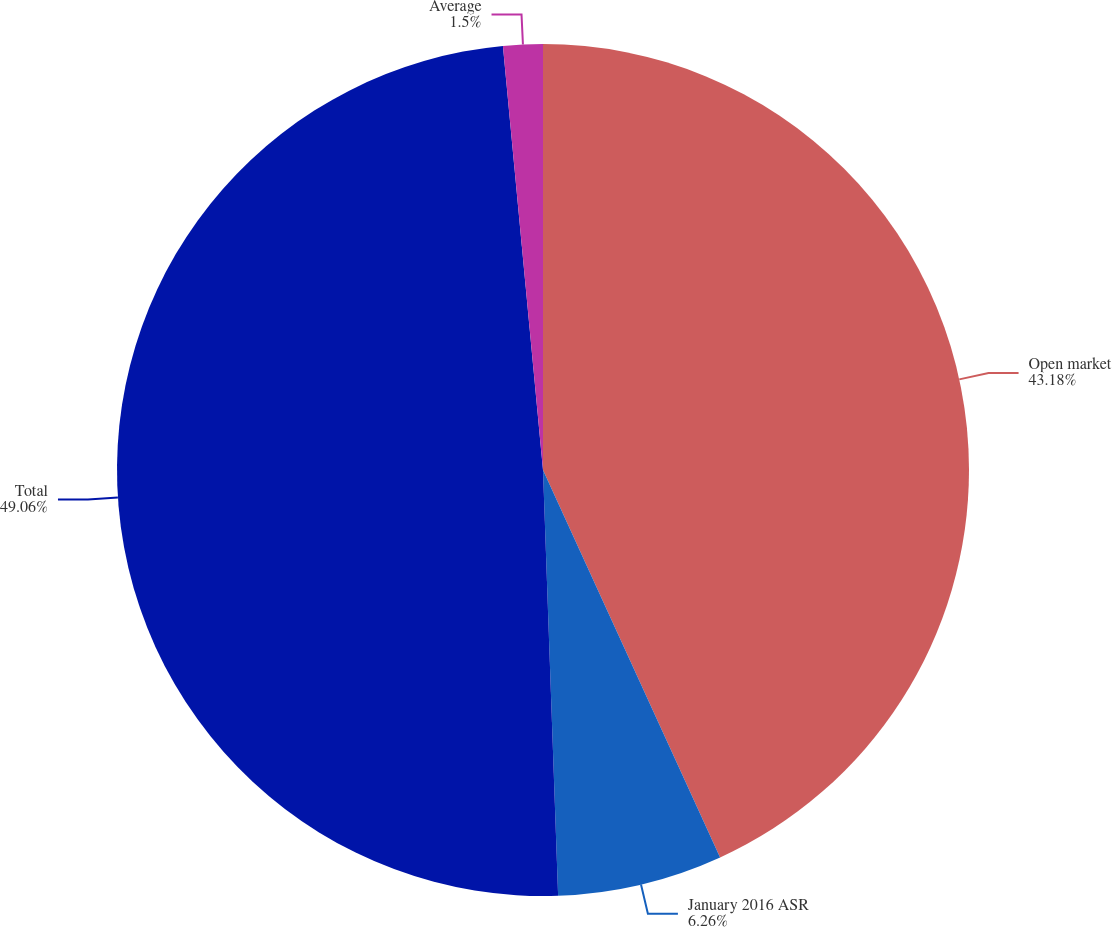Convert chart to OTSL. <chart><loc_0><loc_0><loc_500><loc_500><pie_chart><fcel>Open market<fcel>January 2016 ASR<fcel>Total<fcel>Average<nl><fcel>43.18%<fcel>6.26%<fcel>49.07%<fcel>1.5%<nl></chart> 